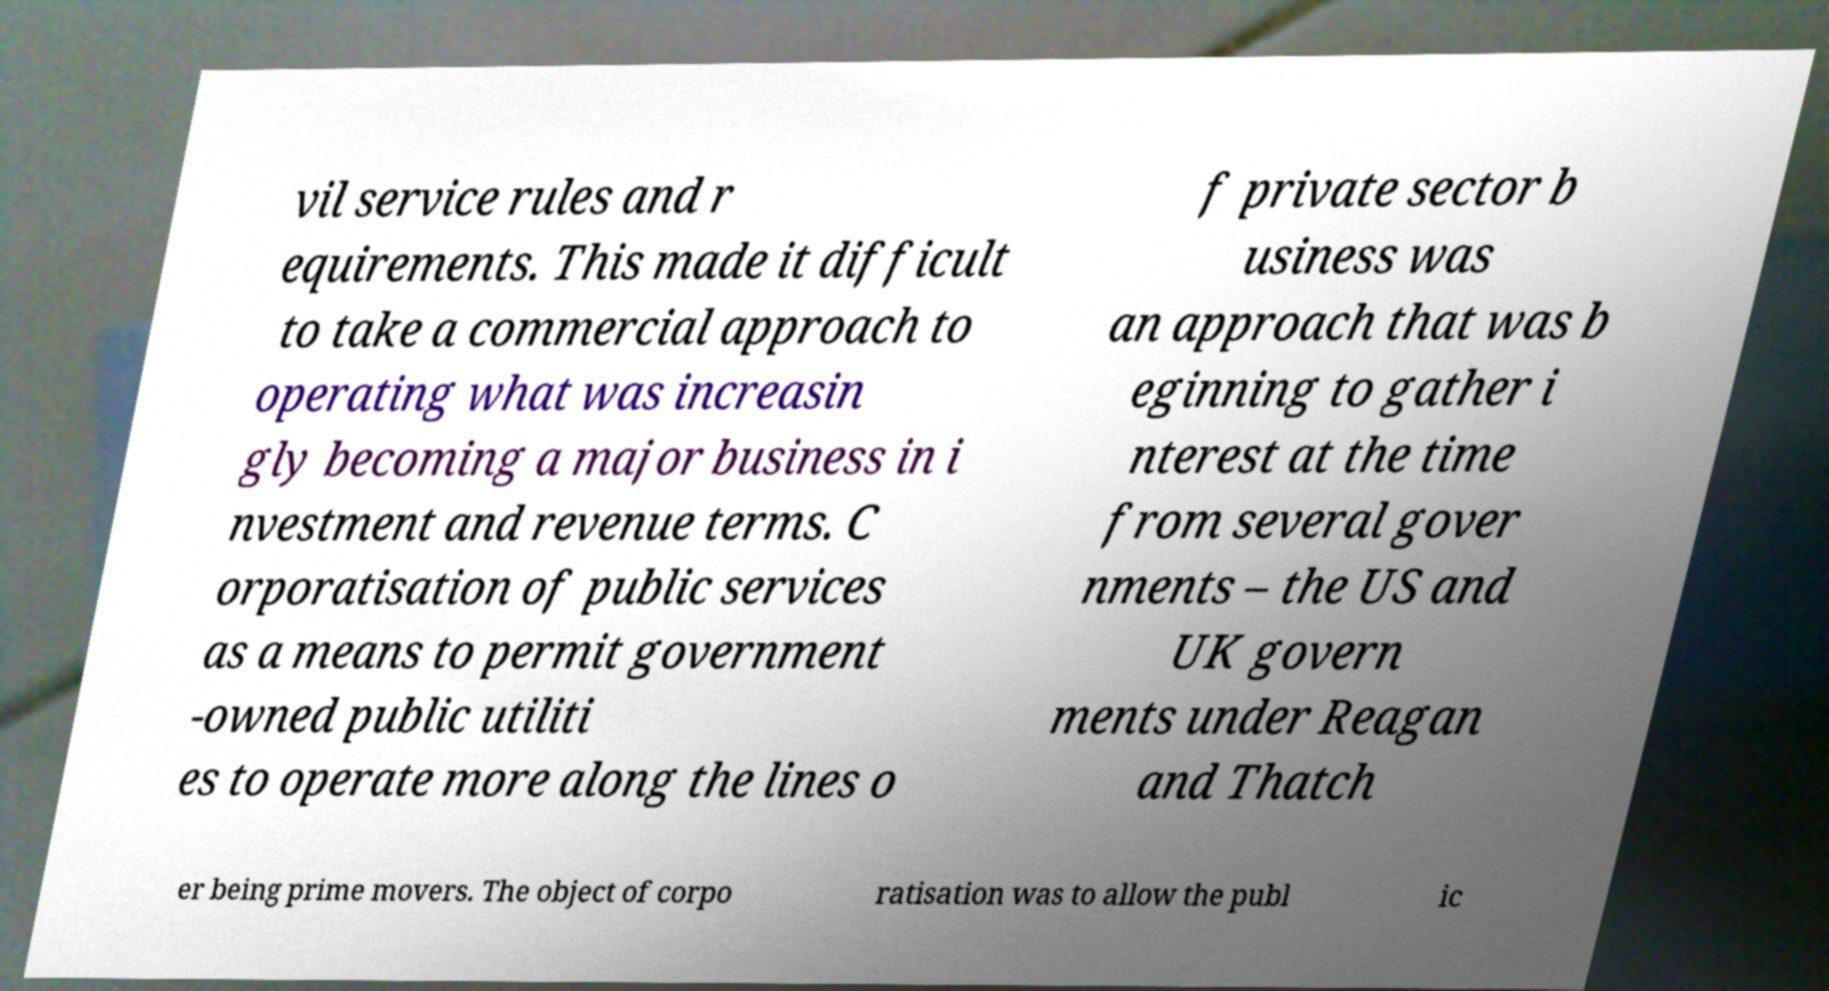Please read and relay the text visible in this image. What does it say? vil service rules and r equirements. This made it difficult to take a commercial approach to operating what was increasin gly becoming a major business in i nvestment and revenue terms. C orporatisation of public services as a means to permit government -owned public utiliti es to operate more along the lines o f private sector b usiness was an approach that was b eginning to gather i nterest at the time from several gover nments – the US and UK govern ments under Reagan and Thatch er being prime movers. The object of corpo ratisation was to allow the publ ic 